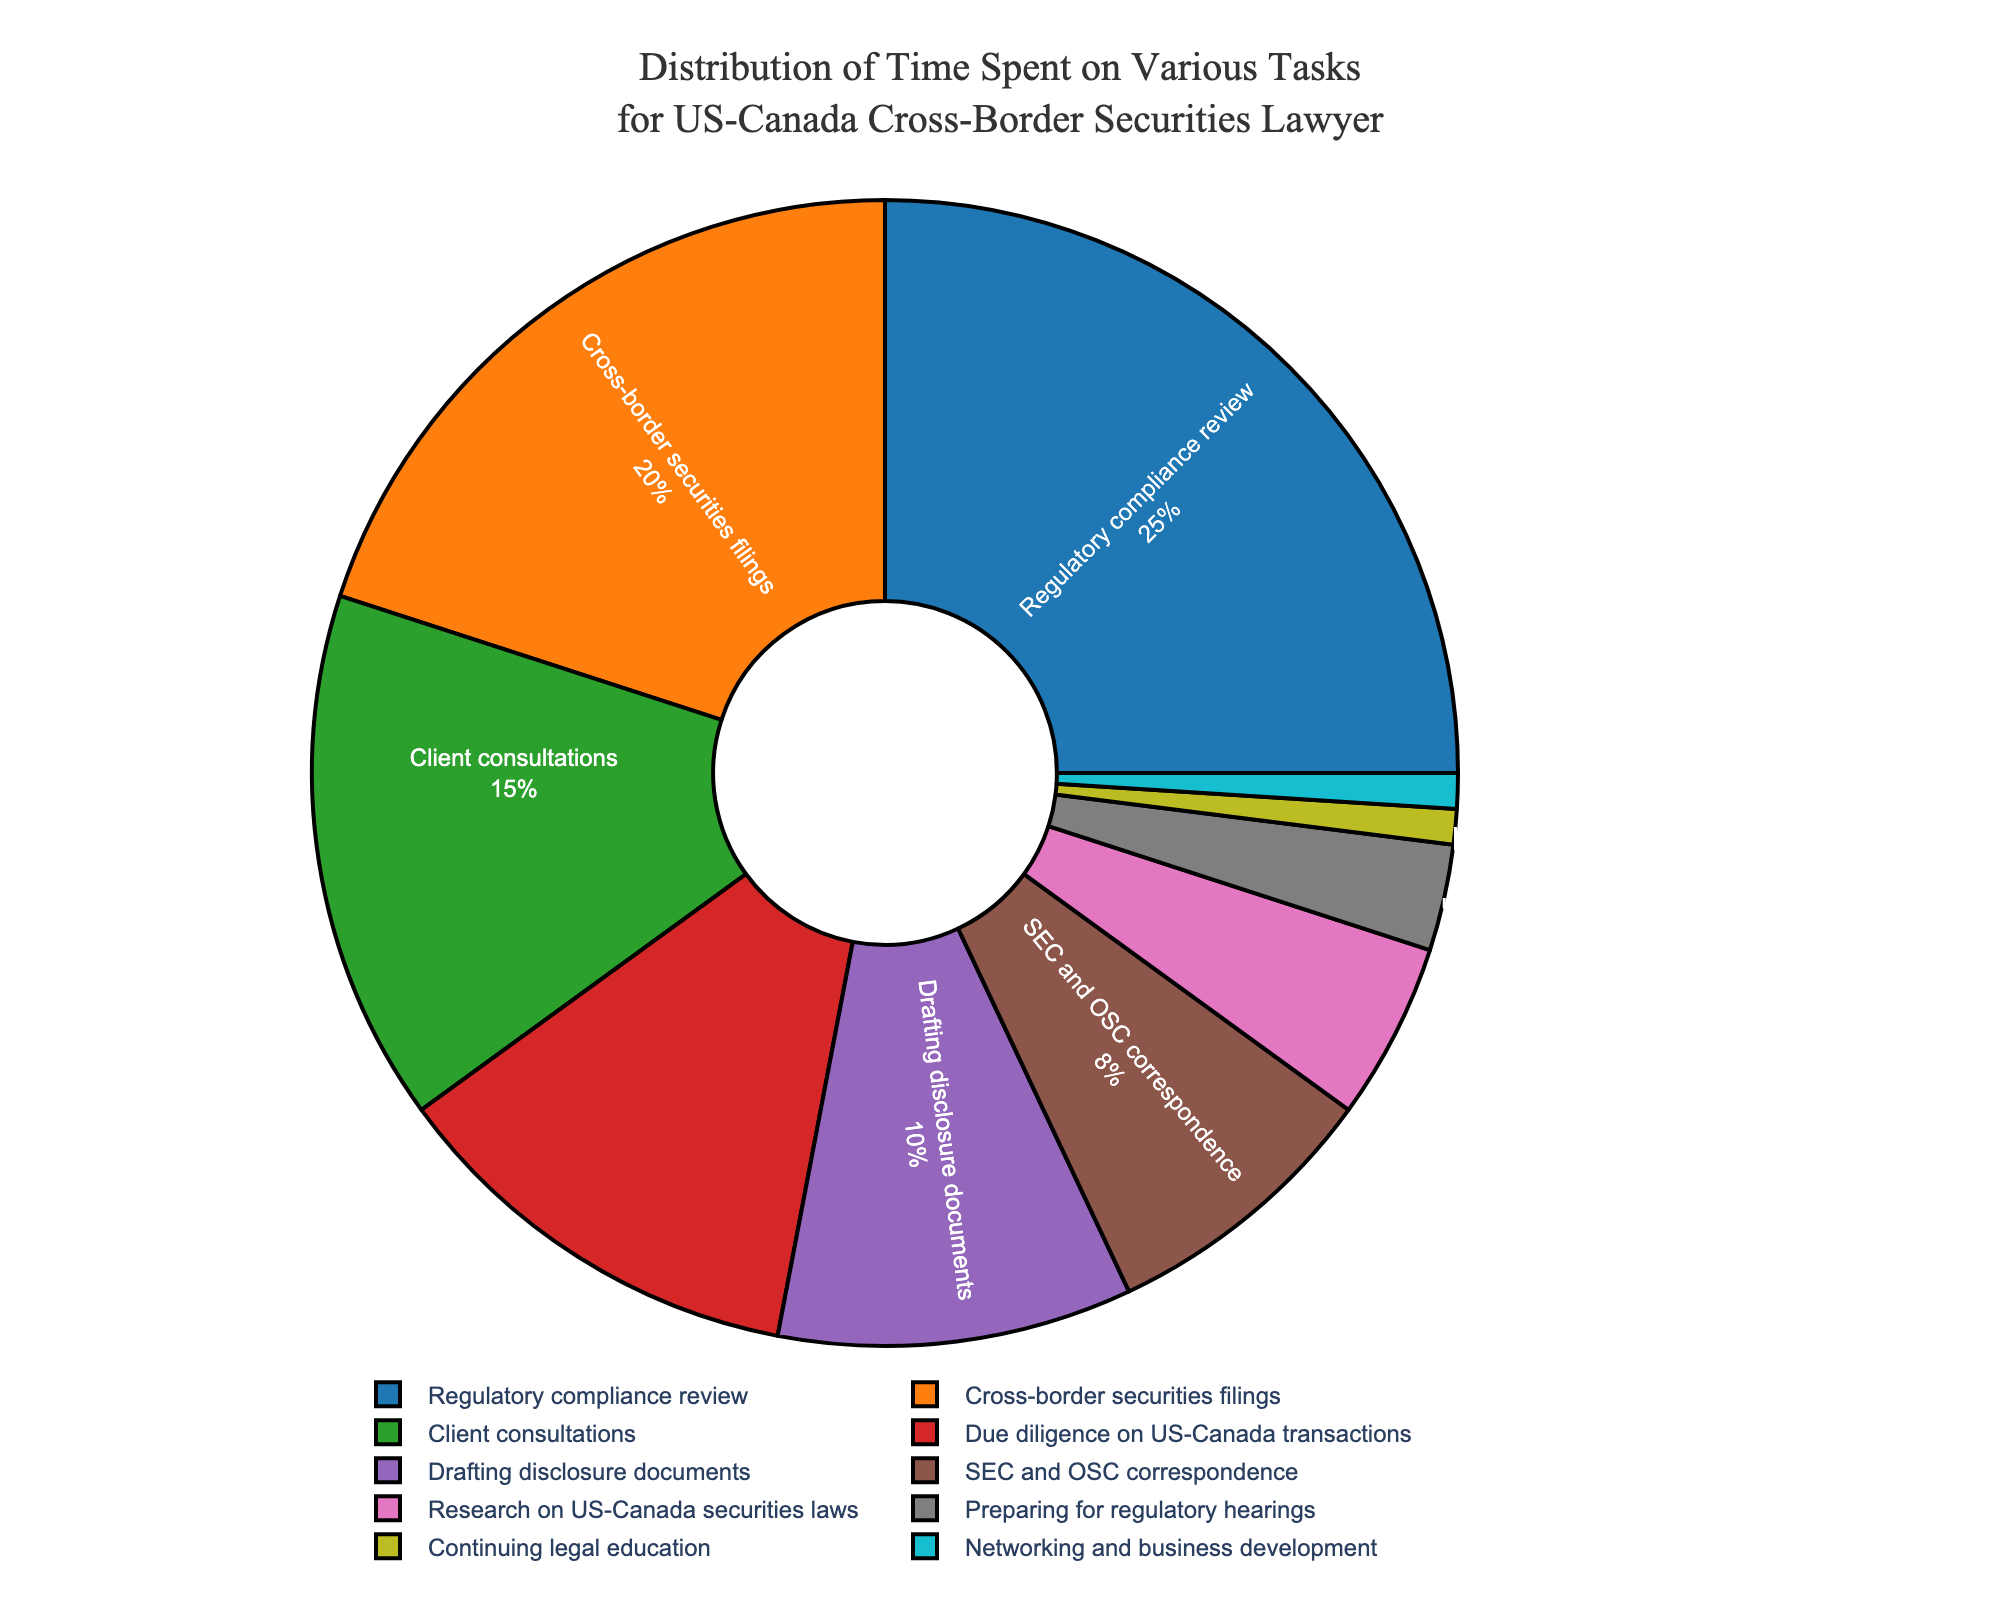What task takes up the most time for a securities lawyer handling US-Canada cross-border cases? Look at the pie chart and identify the segment with the largest percentage. The "Regulatory compliance review" segment takes up 25% of the time, which is the highest.
Answer: Regulatory compliance review How much more time is spent on cross-border securities filings compared to drafting disclosure documents? Identify the percentages for "Cross-border securities filings" (20%) and "Drafting disclosure documents" (10%). Calculate the difference: 20% - 10% = 10%.
Answer: 10% What is the combined percentage of time spent on client consultations and due diligence on US-Canada transactions? Find the percentages for "Client consultations" (15%) and "Due diligence on US-Canada transactions" (12%). Sum them up: 15% + 12% = 27%.
Answer: 27% Which tasks are allocated the least amount of time and what are their combined percentages? Identify the tasks with the smallest percentages: "Continuing legal education" and "Networking and business development," both at 1%. Sum the percentages: 1% + 1% = 2%.
Answer: Continuing legal education and Networking and business development, 2% Is more time spent on SEC and OSC correspondence or on research on US-Canada securities laws? Compare the percentages for "SEC and OSC correspondence" (8%) and "Research on US-Canada securities laws" (5%). 8% is greater than 5%.
Answer: SEC and OSC correspondence What is the total percentage of time spent on tasks related to direct interactions with clients and regulatory authorities? Sum the percentages for "Client consultations" (15%) and "SEC and OSC correspondence" (8%): 15% + 8% = 23%.
Answer: 23% How does the time spent on drafting disclosure documents compare to the time spent on preparing for regulatory hearings? Compare the percentages for "Drafting disclosure documents" (10%) and "Preparing for regulatory hearings" (3%). 10% is greater than 3%.
Answer: Drafting disclosure documents What fraction of the time is spent on activities other than regulatory compliance review and cross-border securities filings? Sum the percentages for all tasks and subtract the combined percentage of "Regulatory compliance review" (25%) and "Cross-border securities filings" (20%): 100% - (25% + 20%) = 55%.
Answer: 55% Excluding the largest task, what is the average time spent on the remaining tasks? Exclude "Regulatory compliance review" (25%). Sum the percentages of the remaining tasks and divide by the number of those tasks (9): (20% + 15% + 12% + 10% + 8% + 5% + 3% + 1% + 1%) / 9 = 75% / 9 ≈ 8.33%.
Answer: 8.33% Which visual attribute helps identify the task with the smallest percentage of time spent? Look at the pie chart for the smallest segment based on area size, which corresponds to the smallest value (1% sections "Continuing legal education" and "Networking and business development").
Answer: Smallest segment size 